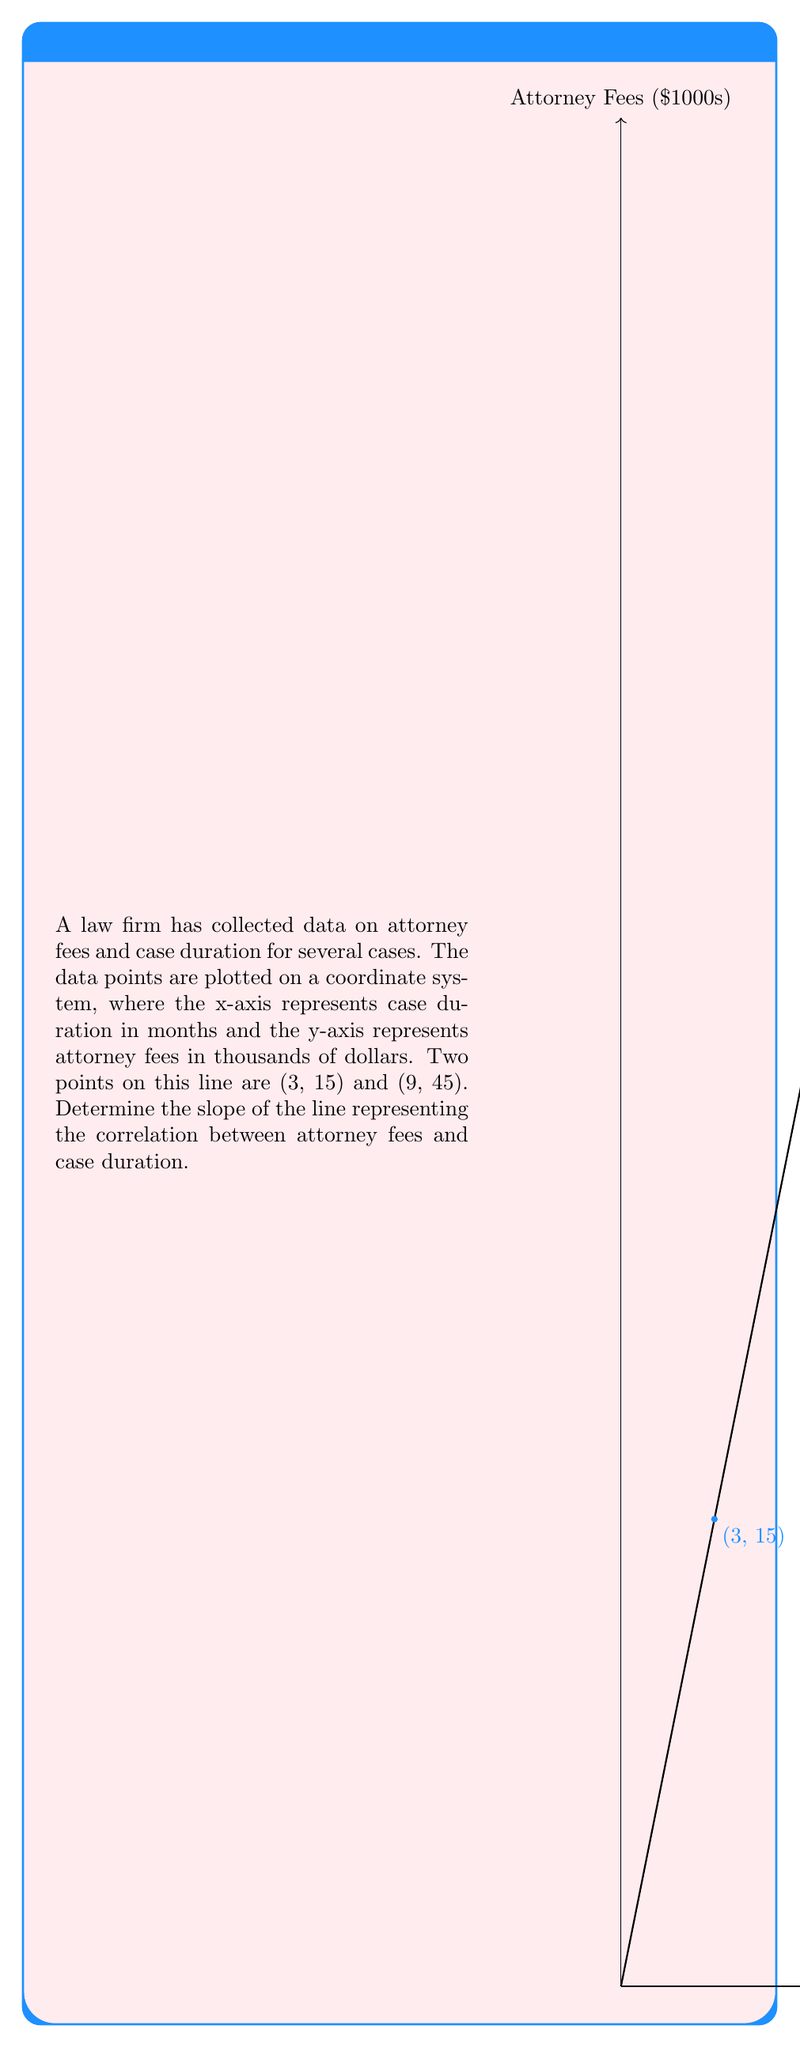What is the answer to this math problem? To find the slope of a line given two points, we use the slope formula:

$$ \text{slope} = m = \frac{y_2 - y_1}{x_2 - x_1} $$

Where $(x_1, y_1)$ and $(x_2, y_2)$ are two points on the line.

Given points: (3, 15) and (9, 45)

Step 1: Identify the coordinates
$x_1 = 3$, $y_1 = 15$
$x_2 = 9$, $y_2 = 45$

Step 2: Substitute these values into the slope formula
$$ m = \frac{45 - 15}{9 - 3} = \frac{30}{6} $$

Step 3: Simplify the fraction
$$ m = 5 $$

The slope of the line is 5, which means for every 1 month increase in case duration, the attorney fees increase by $5,000.
Answer: $5$ 